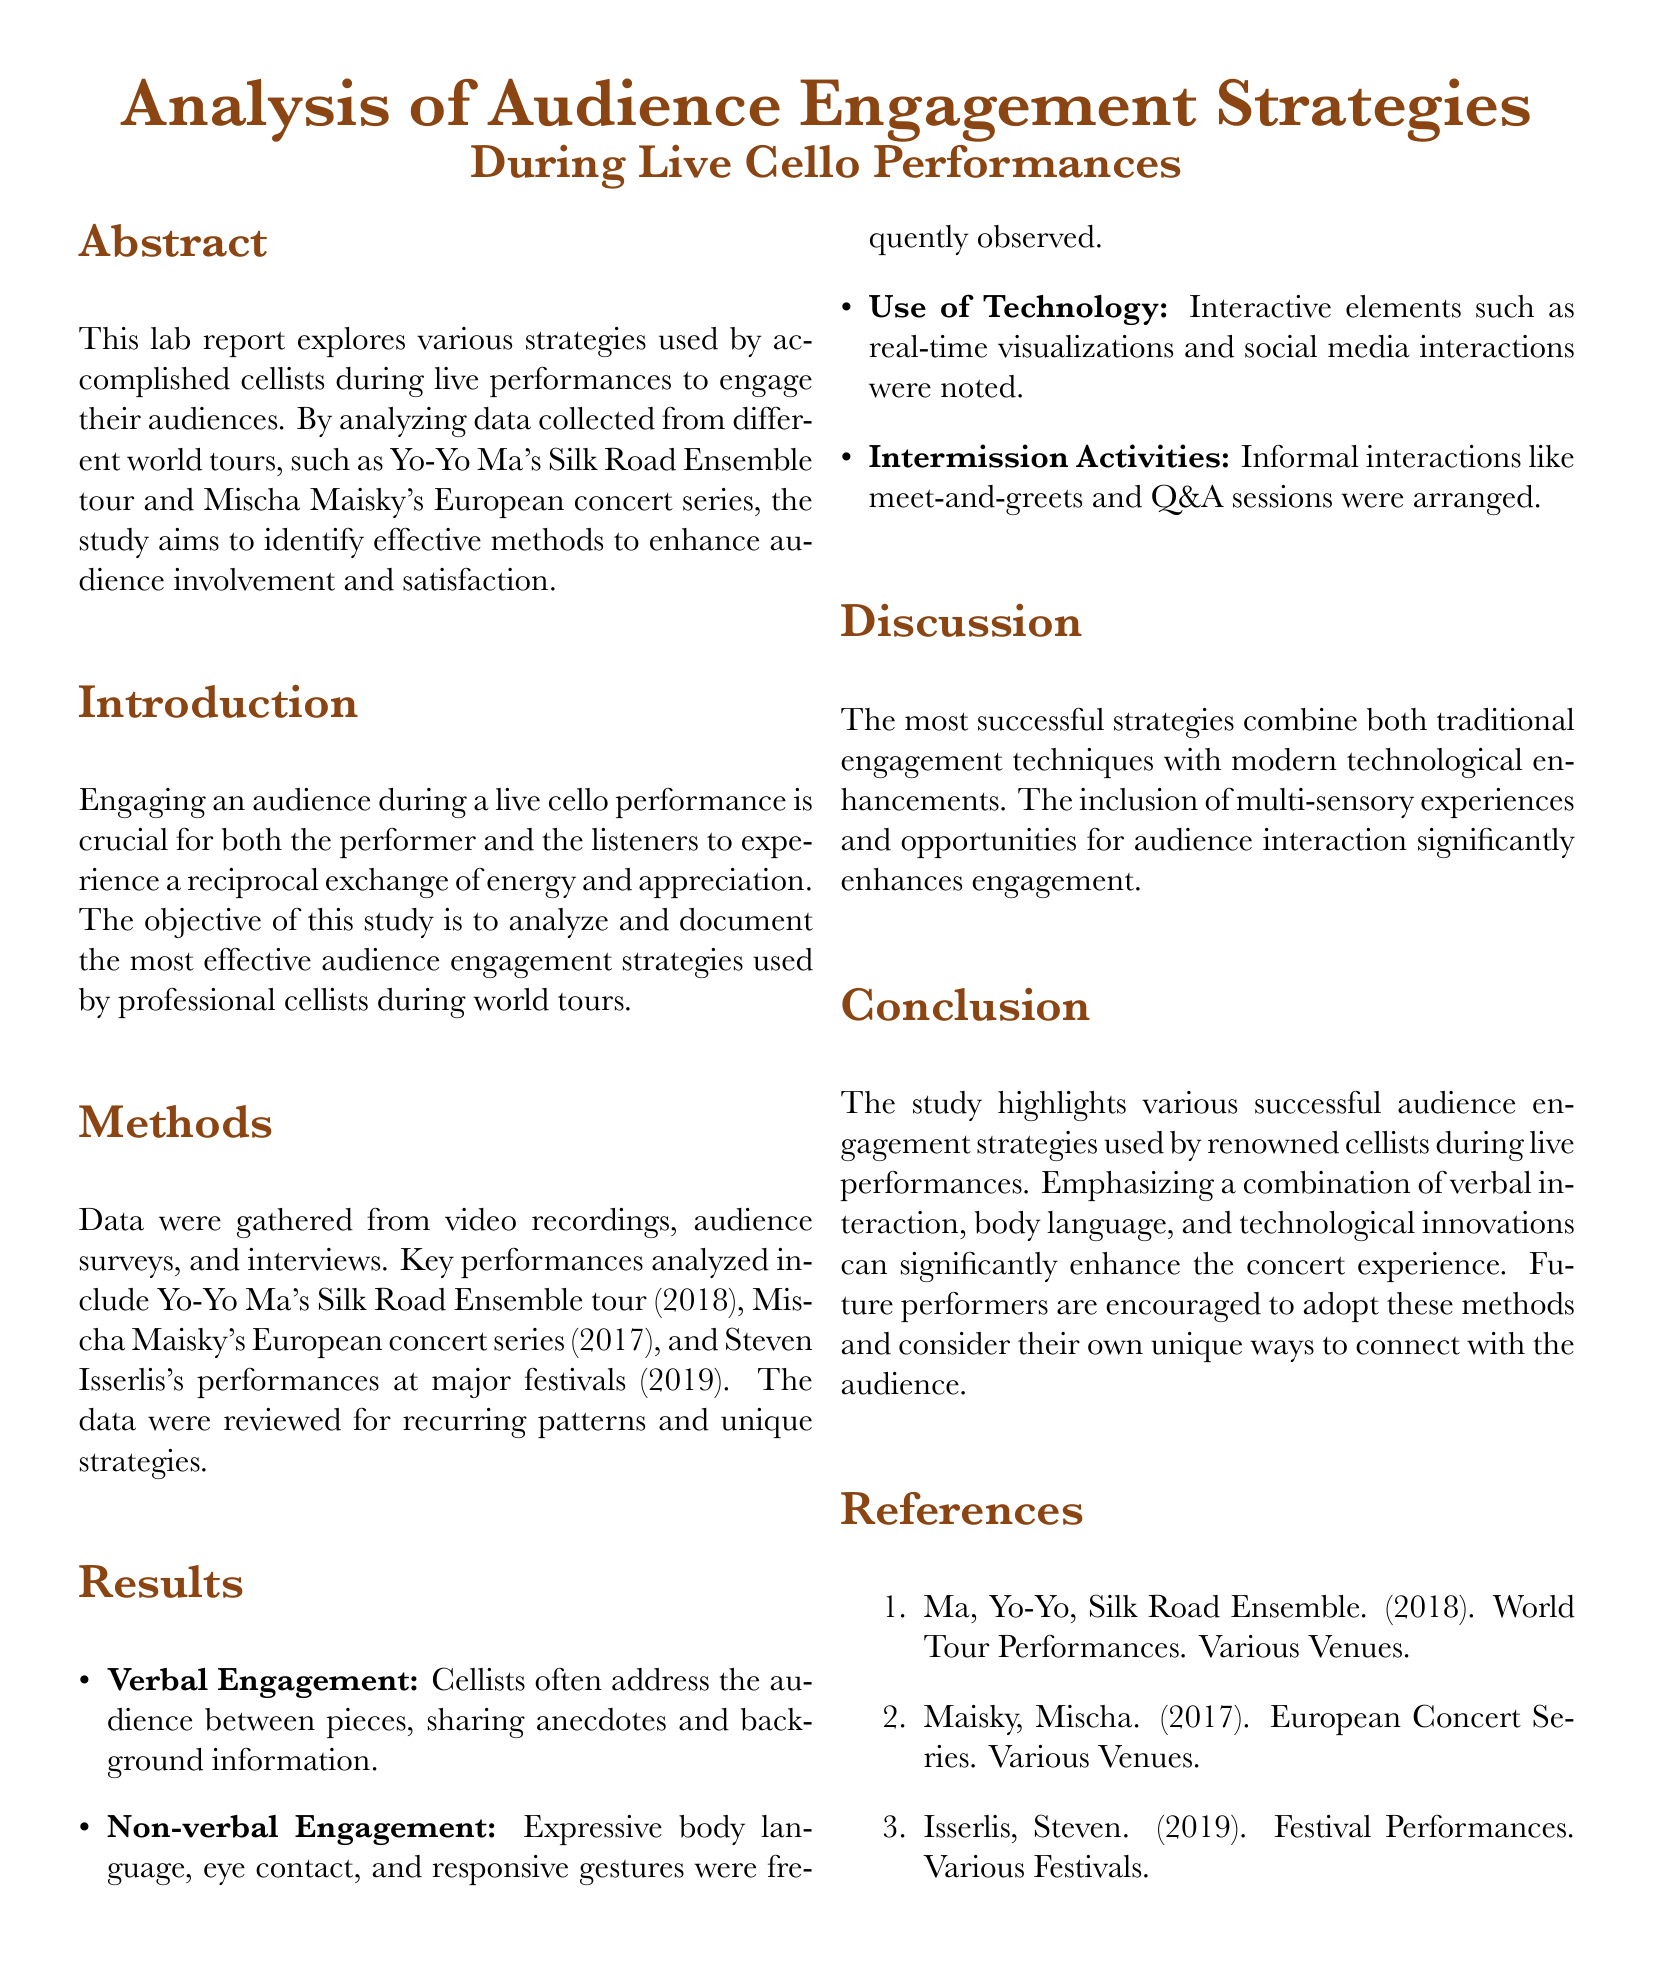What is the title of the lab report? The title is stated at the beginning of the document, describing the focus of the analysis.
Answer: Analysis of Audience Engagement Strategies During Live Cello Performances Who is one of the cellists mentioned in the study? The report lists notable cellists whose performances were analyzed for engagement strategies.
Answer: Yo-Yo Ma What year did Mischa Maisky's European Concert Series take place? The document provides specific years for the performances included in the study.
Answer: 2017 What strategy involves sharing anecdotes and background information? The results section categorizes engagement strategies, and this describes one of them.
Answer: Verbal Engagement What type of engagement includes body language and eye contact? The report delineates different forms of audience engagement used by cellists.
Answer: Non-verbal Engagement Which modern element was noted as part of the engagement strategies? The strategies analyzed include both traditional and modern elements that enhance audience involvement.
Answer: Technology How many key performances were analyzed in this study? The introduction summarizes the performances assessed in the research.
Answer: Three What were arranged during intermission? This detail is mentioned under the results to highlight informal audience interactions.
Answer: Meet-and-greets What is the primary goal of the study? The introduction states the main objective of the research, focusing on audience involvement.
Answer: Analyze and document effective audience engagement strategies 